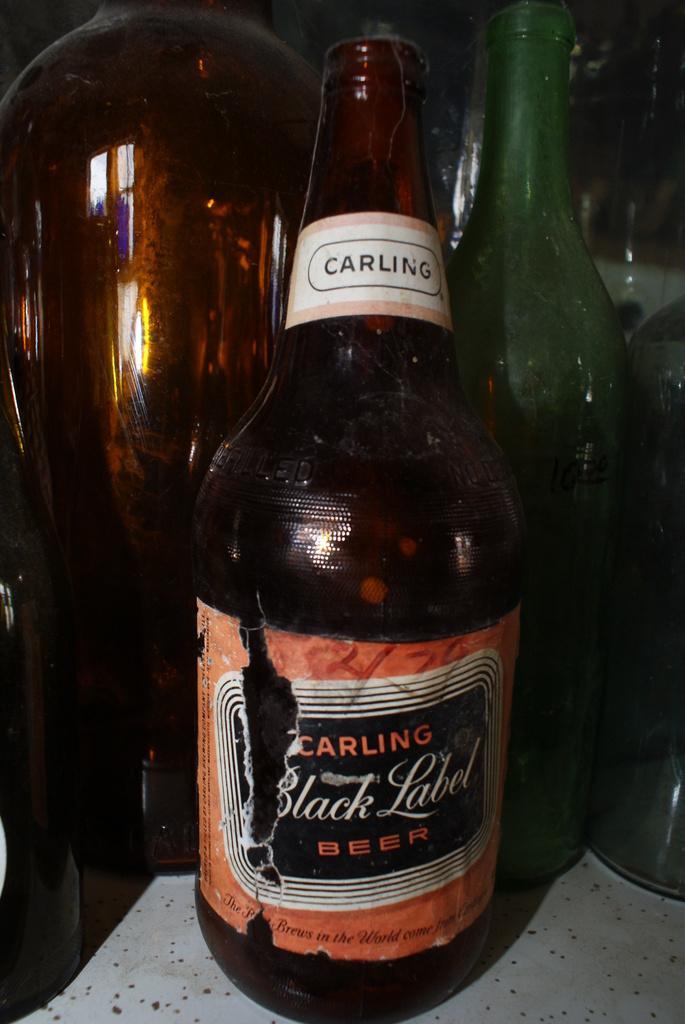Please provide a concise description of this image. As we can see in the image there are few bottles. 